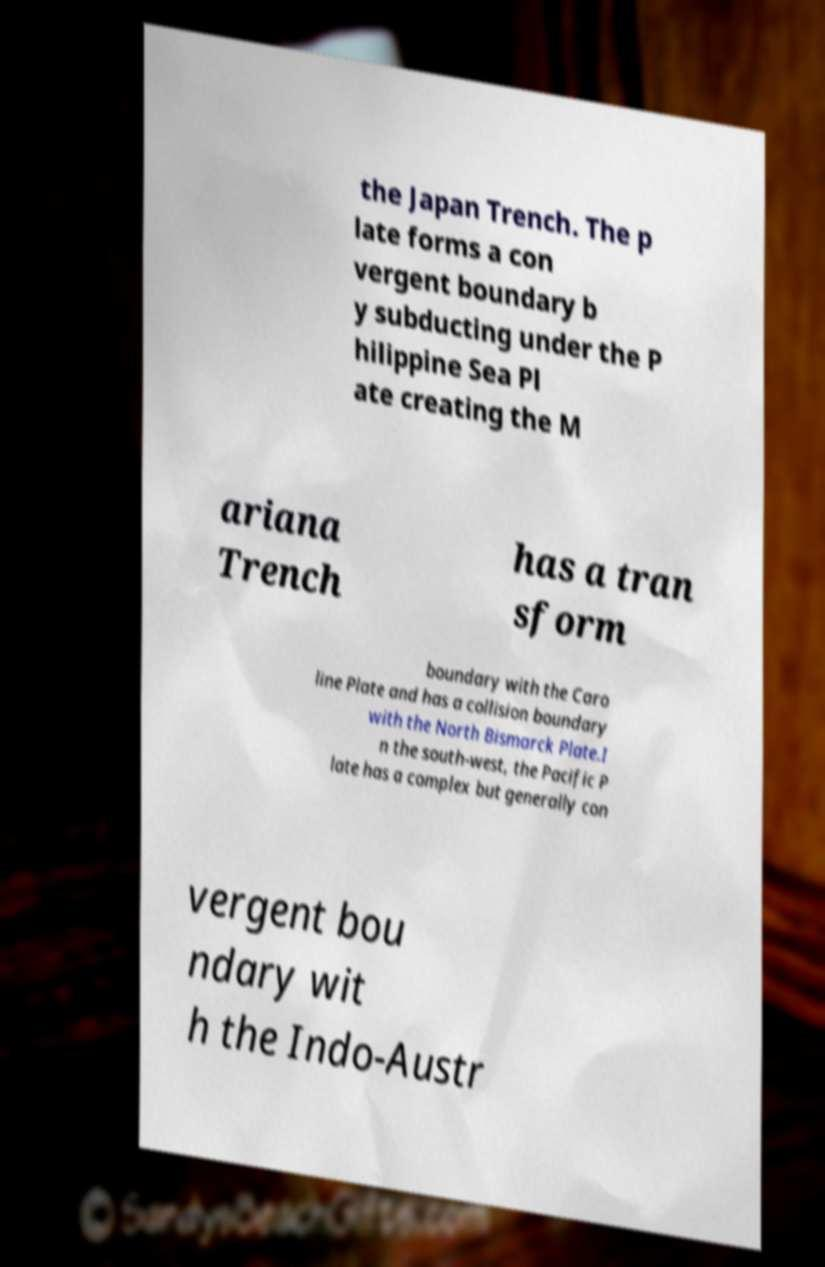Please identify and transcribe the text found in this image. the Japan Trench. The p late forms a con vergent boundary b y subducting under the P hilippine Sea Pl ate creating the M ariana Trench has a tran sform boundary with the Caro line Plate and has a collision boundary with the North Bismarck Plate.I n the south-west, the Pacific P late has a complex but generally con vergent bou ndary wit h the Indo-Austr 